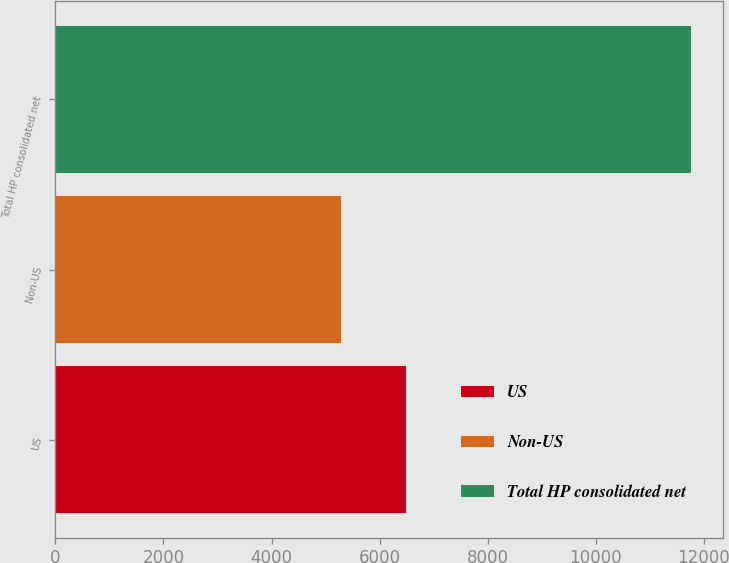Convert chart. <chart><loc_0><loc_0><loc_500><loc_500><bar_chart><fcel>US<fcel>Non-US<fcel>Total HP consolidated net<nl><fcel>6479<fcel>5284<fcel>11763<nl></chart> 